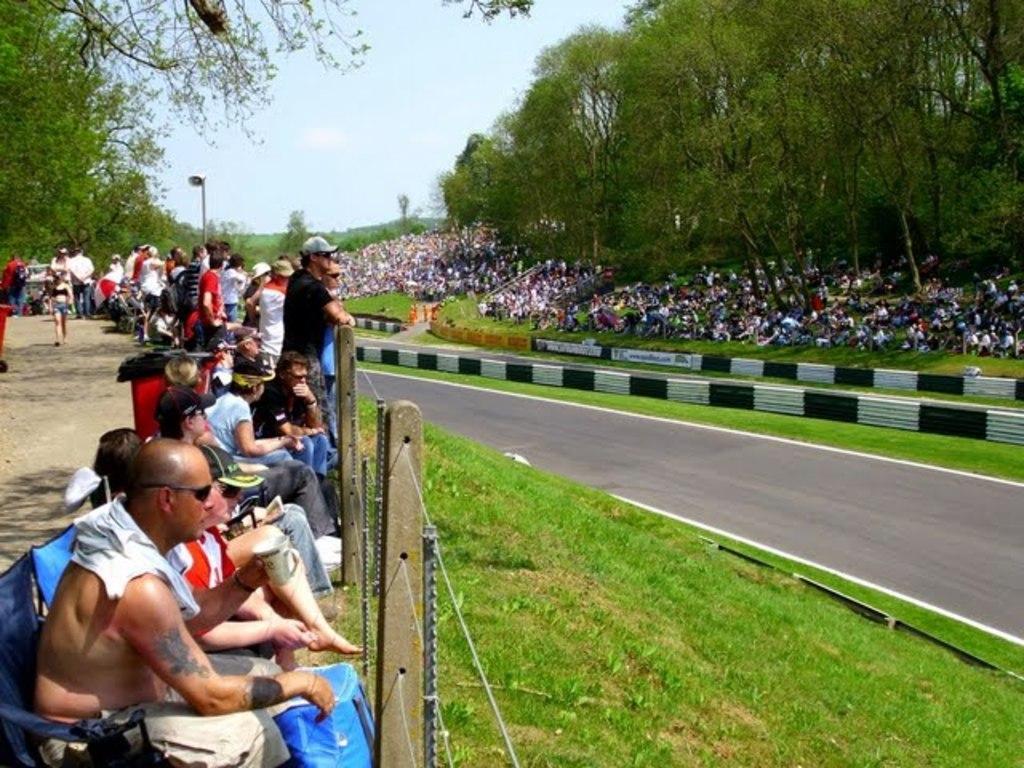In one or two sentences, can you explain what this image depicts? In this image, there is an outside view. There are some persons on the left side of the image standing beside the road. There are some other persons in the bottom left of the image sitting on chairs in front the fencing. There is a sky at the top of the image. There are some tree in the top left and in the top right of the image. There is a road on the right side of the image. 